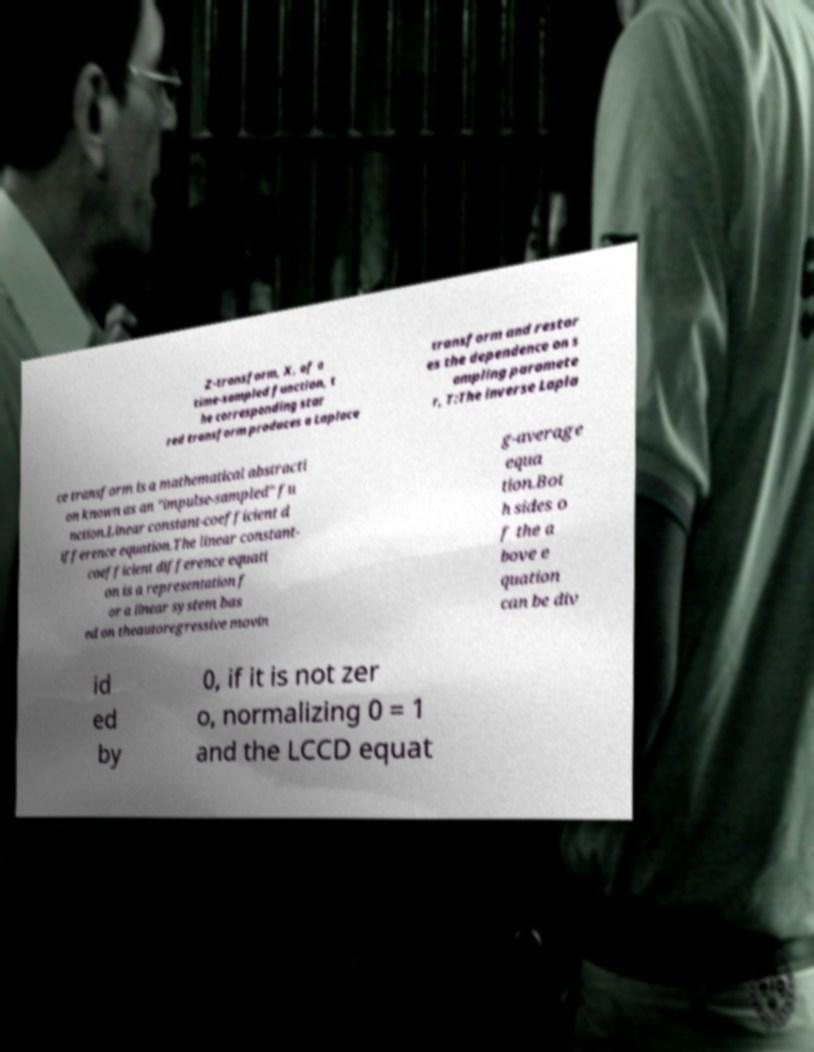Please read and relay the text visible in this image. What does it say? Z-transform, X, of a time-sampled function, t he corresponding star red transform produces a Laplace transform and restor es the dependence on s ampling paramete r, T:The inverse Lapla ce transform is a mathematical abstracti on known as an "impulse-sampled" fu nction.Linear constant-coefficient d ifference equation.The linear constant- coefficient difference equati on is a representation f or a linear system bas ed on theautoregressive movin g-average equa tion.Bot h sides o f the a bove e quation can be div id ed by 0, if it is not zer o, normalizing 0 = 1 and the LCCD equat 